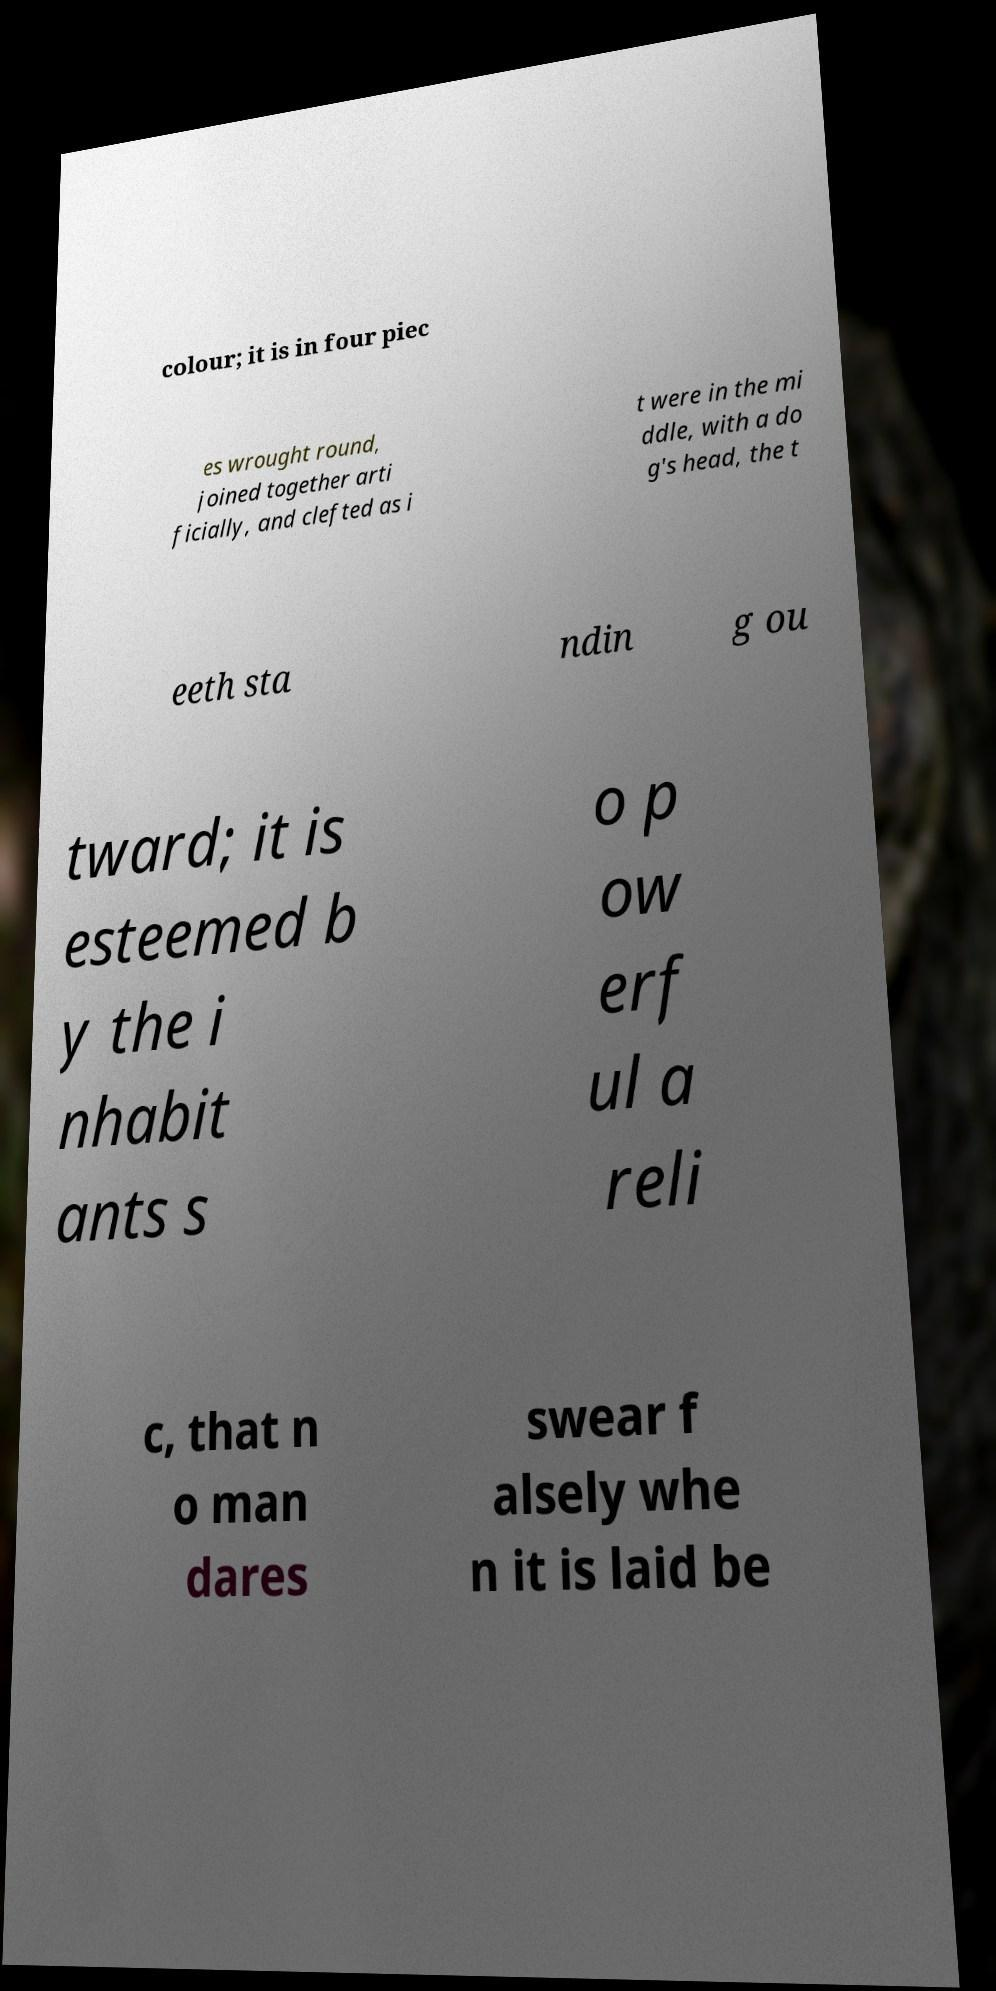Can you accurately transcribe the text from the provided image for me? colour; it is in four piec es wrought round, joined together arti ficially, and clefted as i t were in the mi ddle, with a do g's head, the t eeth sta ndin g ou tward; it is esteemed b y the i nhabit ants s o p ow erf ul a reli c, that n o man dares swear f alsely whe n it is laid be 